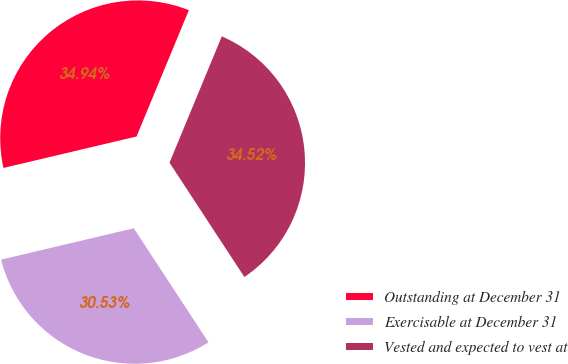<chart> <loc_0><loc_0><loc_500><loc_500><pie_chart><fcel>Outstanding at December 31<fcel>Exercisable at December 31<fcel>Vested and expected to vest at<nl><fcel>34.94%<fcel>30.53%<fcel>34.52%<nl></chart> 